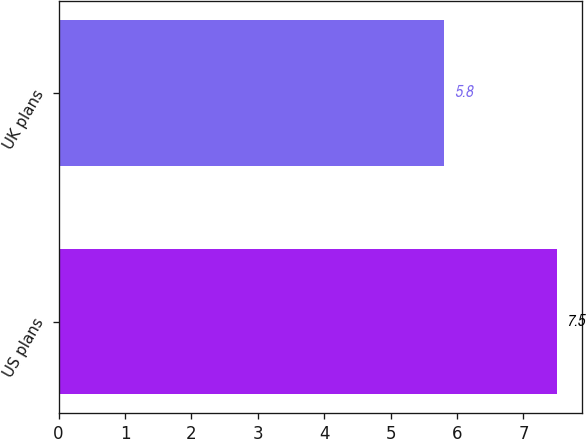Convert chart. <chart><loc_0><loc_0><loc_500><loc_500><bar_chart><fcel>US plans<fcel>UK plans<nl><fcel>7.5<fcel>5.8<nl></chart> 